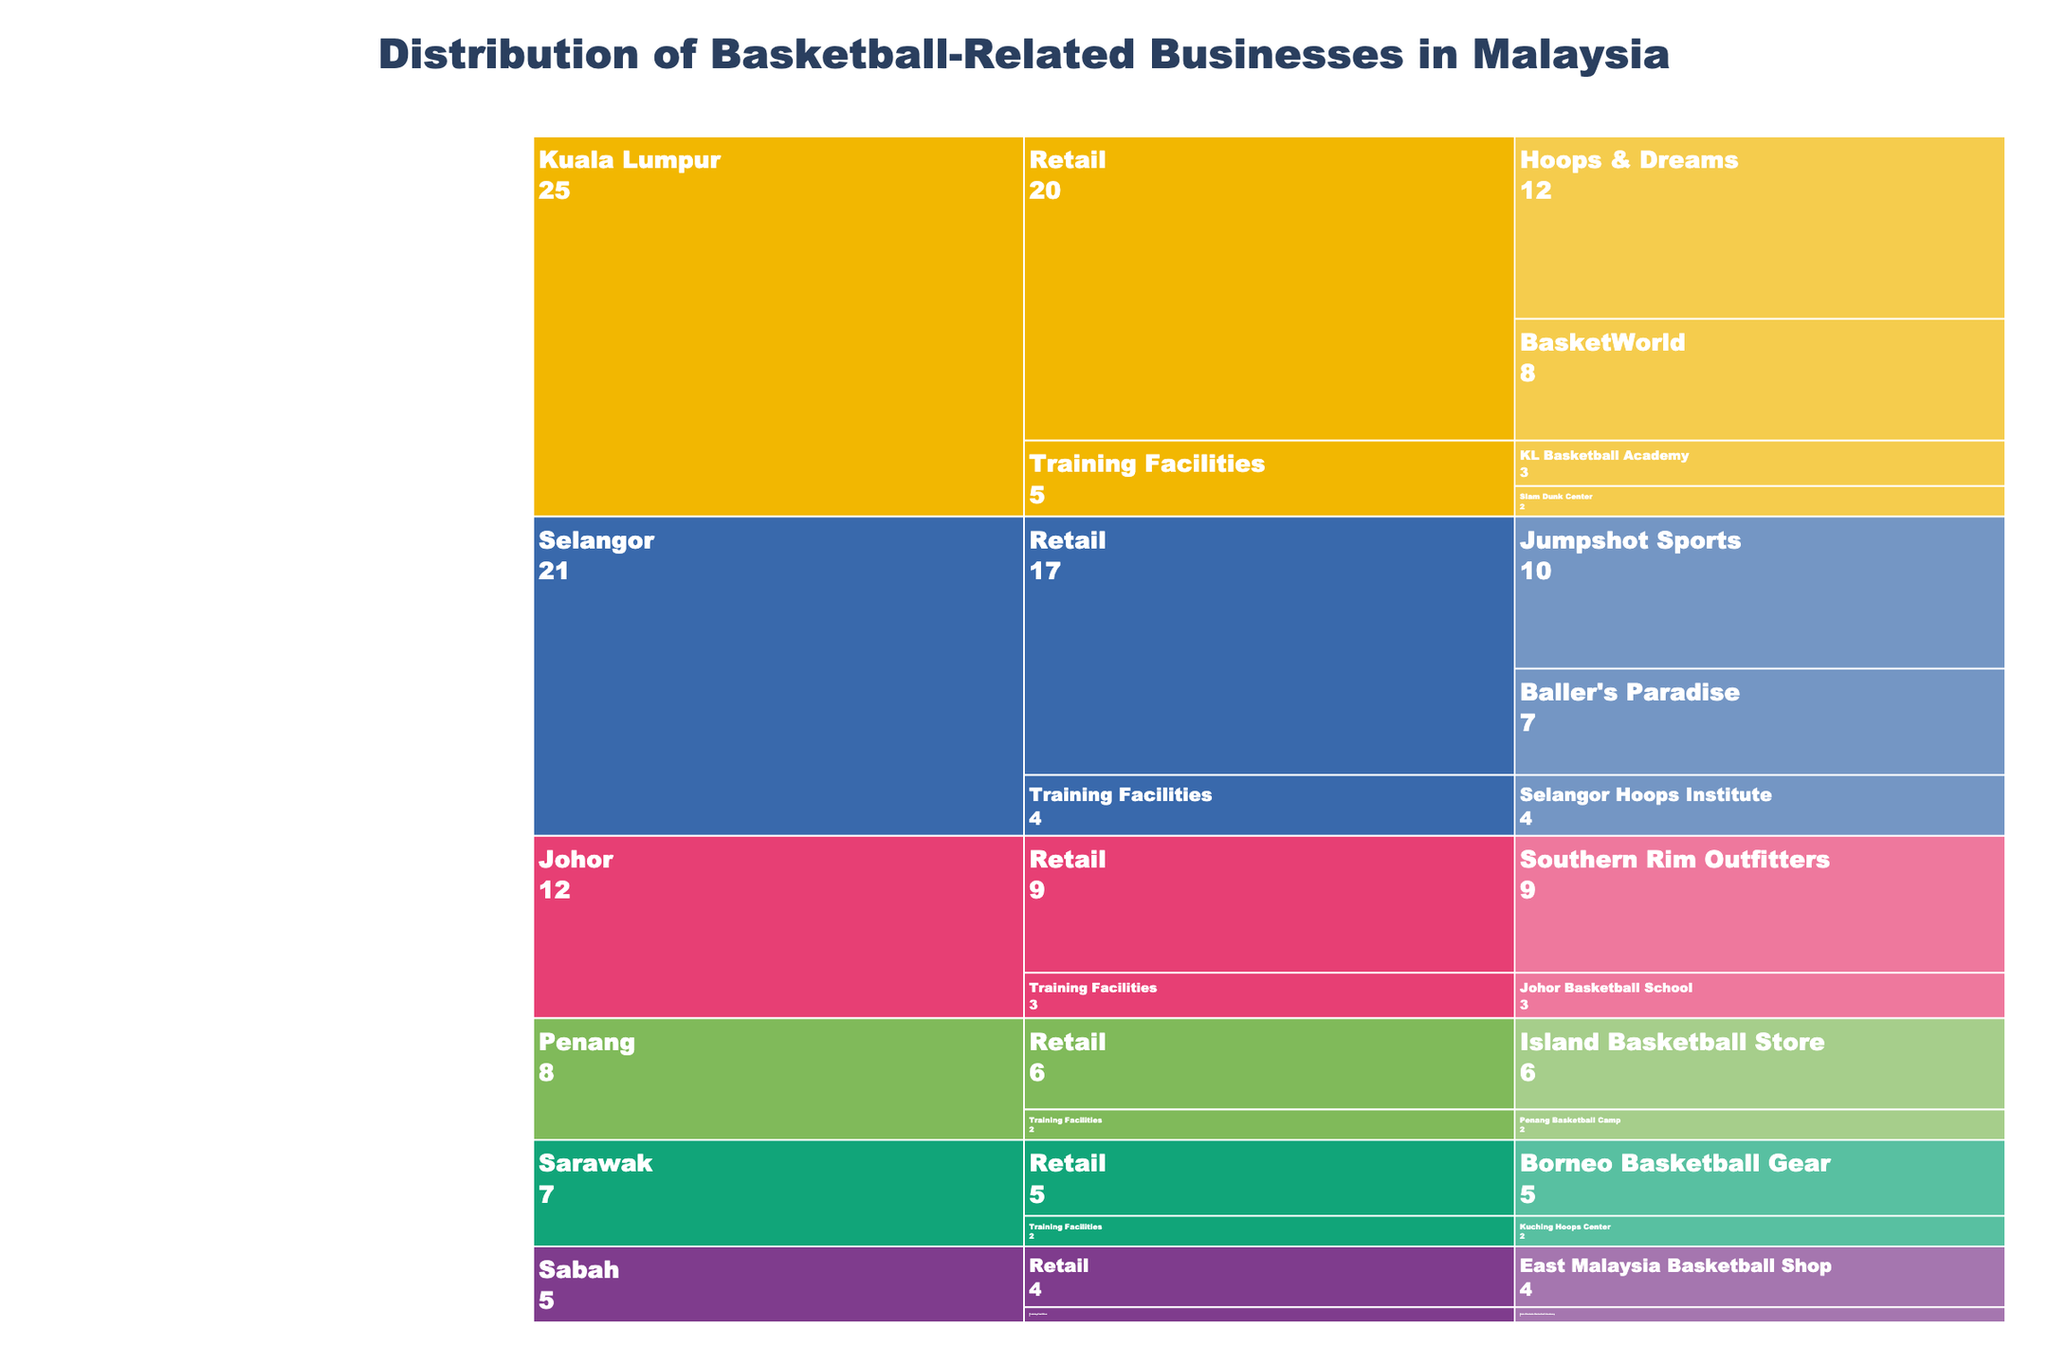What's the title of the chart? The title can be seen at the top of the chart, centered and in a larger font size.
Answer: Distribution of Basketball-Related Businesses in Malaysia Which region has the highest number of retail businesses? Look at the regions in the icicle chart and find which one has the largest values summed for 'Retail' sections.
Answer: Kuala Lumpur How many training facilities are there in Sarawak? Navigate to the Sarawak section and sum up the values for the 'Training Facilities' sub-sections.
Answer: 2 Which business has the most branches in Kuala Lumpur? Within the Kuala Lumpur region, look at the 'Retail' and 'Training Facilities' sub-sections and identify which business has the largest count.
Answer: Hoops & Dreams What's the total number of basketball-related businesses in Malaysia? Sum the values of all the businesses shown in the icicle chart.
Answer: 78 How many more retail businesses are there in Johor compared to Sabah? Find the counts for retail businesses in Johor and Sabah, then compute the difference. Johor: 9, Sabah: 4, Difference = 9 - 4
Answer: 5 Which region has the least number of businesses and how many do they have? Compare the summed values of all businesses for each region from the chart and identify the smallest sum.
Answer: Sabah, 5 Compare the number of retail businesses in Penang and Selangor. Which has more and by how much? Look at the 'Retail' sub-sections for Penang and Selangor and compute the difference. Penang: 6, Selangor: 17, Difference = 17 - 6
Answer: Selangor by 11 What percentage of the businesses in Kuala Lumpur are training facilities? Sum the counts for training facilities and divide by the total count for Kuala Lumpur, then multiply by 100. Total in KL: 25, Training Facilities: 5, (5/25)*100%
Answer: 20% Which training facility has the smallest number and where is it located? Look through all the 'Training Facilities' sub-sections to find the one with the smallest count.
Answer: Kota Kinabalu Basketball Academy in Sabah 